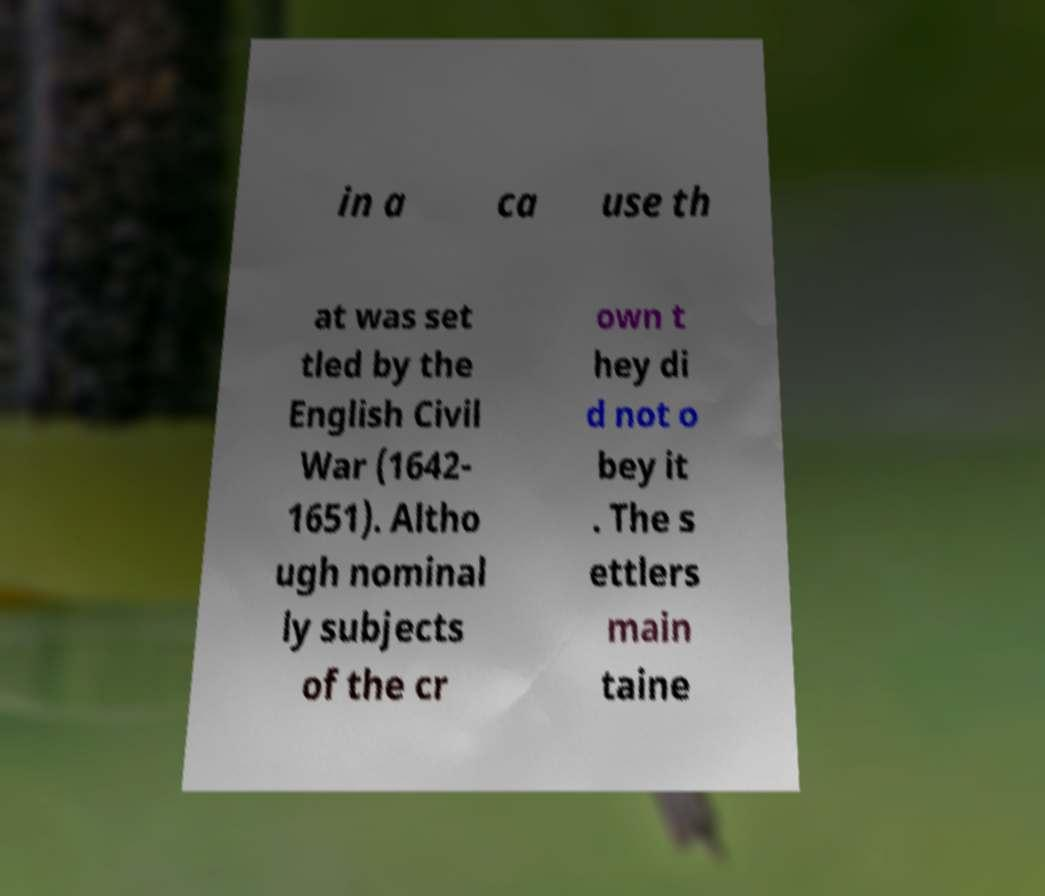Can you accurately transcribe the text from the provided image for me? in a ca use th at was set tled by the English Civil War (1642- 1651). Altho ugh nominal ly subjects of the cr own t hey di d not o bey it . The s ettlers main taine 